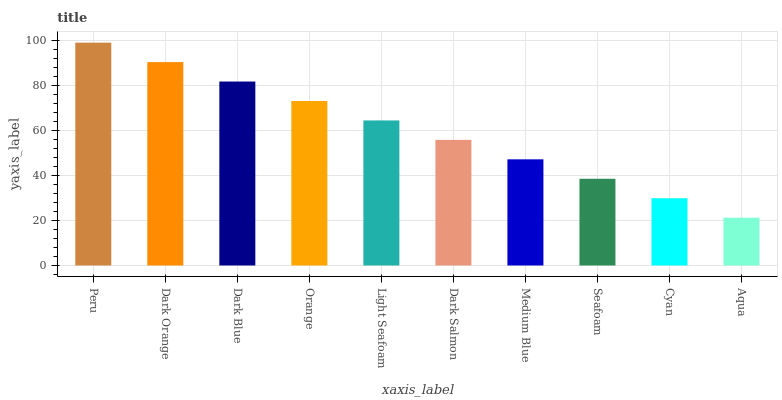Is Aqua the minimum?
Answer yes or no. Yes. Is Peru the maximum?
Answer yes or no. Yes. Is Dark Orange the minimum?
Answer yes or no. No. Is Dark Orange the maximum?
Answer yes or no. No. Is Peru greater than Dark Orange?
Answer yes or no. Yes. Is Dark Orange less than Peru?
Answer yes or no. Yes. Is Dark Orange greater than Peru?
Answer yes or no. No. Is Peru less than Dark Orange?
Answer yes or no. No. Is Light Seafoam the high median?
Answer yes or no. Yes. Is Dark Salmon the low median?
Answer yes or no. Yes. Is Dark Salmon the high median?
Answer yes or no. No. Is Seafoam the low median?
Answer yes or no. No. 